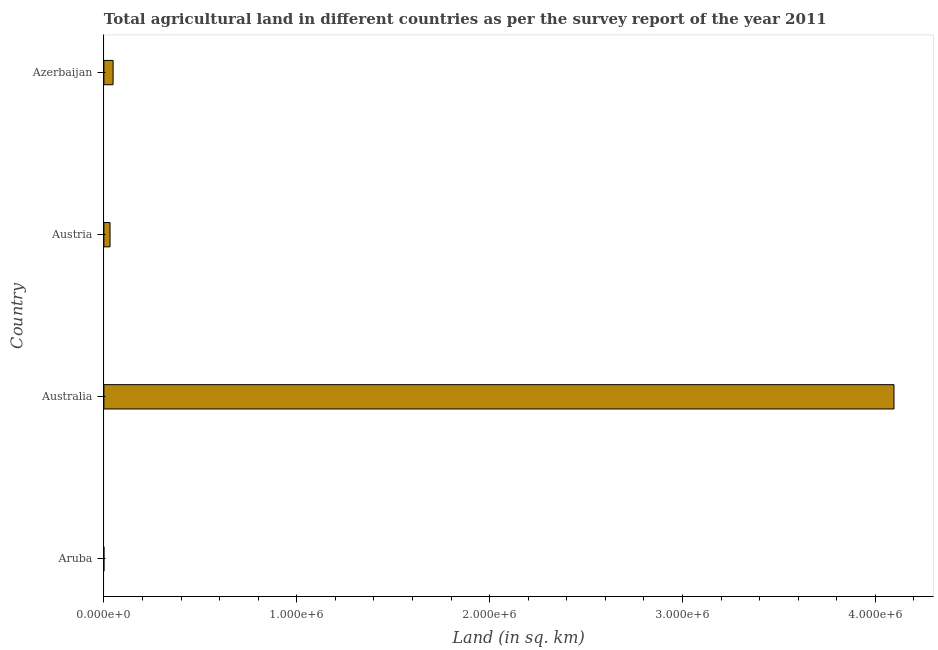What is the title of the graph?
Offer a terse response. Total agricultural land in different countries as per the survey report of the year 2011. What is the label or title of the X-axis?
Your answer should be compact. Land (in sq. km). What is the agricultural land in Austria?
Offer a very short reply. 3.18e+04. Across all countries, what is the maximum agricultural land?
Provide a short and direct response. 4.10e+06. Across all countries, what is the minimum agricultural land?
Your answer should be very brief. 20. In which country was the agricultural land minimum?
Offer a very short reply. Aruba. What is the sum of the agricultural land?
Provide a succinct answer. 4.18e+06. What is the difference between the agricultural land in Aruba and Azerbaijan?
Your response must be concise. -4.77e+04. What is the average agricultural land per country?
Give a very brief answer. 1.04e+06. What is the median agricultural land?
Offer a very short reply. 3.97e+04. In how many countries, is the agricultural land greater than 800000 sq. km?
Ensure brevity in your answer.  1. What is the ratio of the agricultural land in Australia to that in Azerbaijan?
Make the answer very short. 85.91. Is the agricultural land in Australia less than that in Azerbaijan?
Make the answer very short. No. Is the difference between the agricultural land in Austria and Azerbaijan greater than the difference between any two countries?
Your answer should be very brief. No. What is the difference between the highest and the second highest agricultural land?
Keep it short and to the point. 4.05e+06. What is the difference between the highest and the lowest agricultural land?
Ensure brevity in your answer.  4.10e+06. How many bars are there?
Offer a terse response. 4. Are all the bars in the graph horizontal?
Ensure brevity in your answer.  Yes. How many countries are there in the graph?
Provide a short and direct response. 4. Are the values on the major ticks of X-axis written in scientific E-notation?
Offer a terse response. Yes. What is the Land (in sq. km) of Aruba?
Provide a short and direct response. 20. What is the Land (in sq. km) in Australia?
Provide a short and direct response. 4.10e+06. What is the Land (in sq. km) of Austria?
Your answer should be very brief. 3.18e+04. What is the Land (in sq. km) of Azerbaijan?
Ensure brevity in your answer.  4.77e+04. What is the difference between the Land (in sq. km) in Aruba and Australia?
Provide a short and direct response. -4.10e+06. What is the difference between the Land (in sq. km) in Aruba and Austria?
Keep it short and to the point. -3.18e+04. What is the difference between the Land (in sq. km) in Aruba and Azerbaijan?
Keep it short and to the point. -4.77e+04. What is the difference between the Land (in sq. km) in Australia and Austria?
Your response must be concise. 4.06e+06. What is the difference between the Land (in sq. km) in Australia and Azerbaijan?
Make the answer very short. 4.05e+06. What is the difference between the Land (in sq. km) in Austria and Azerbaijan?
Your answer should be very brief. -1.59e+04. What is the ratio of the Land (in sq. km) in Aruba to that in Australia?
Offer a very short reply. 0. What is the ratio of the Land (in sq. km) in Australia to that in Austria?
Offer a very short reply. 128.79. What is the ratio of the Land (in sq. km) in Australia to that in Azerbaijan?
Your response must be concise. 85.91. What is the ratio of the Land (in sq. km) in Austria to that in Azerbaijan?
Make the answer very short. 0.67. 